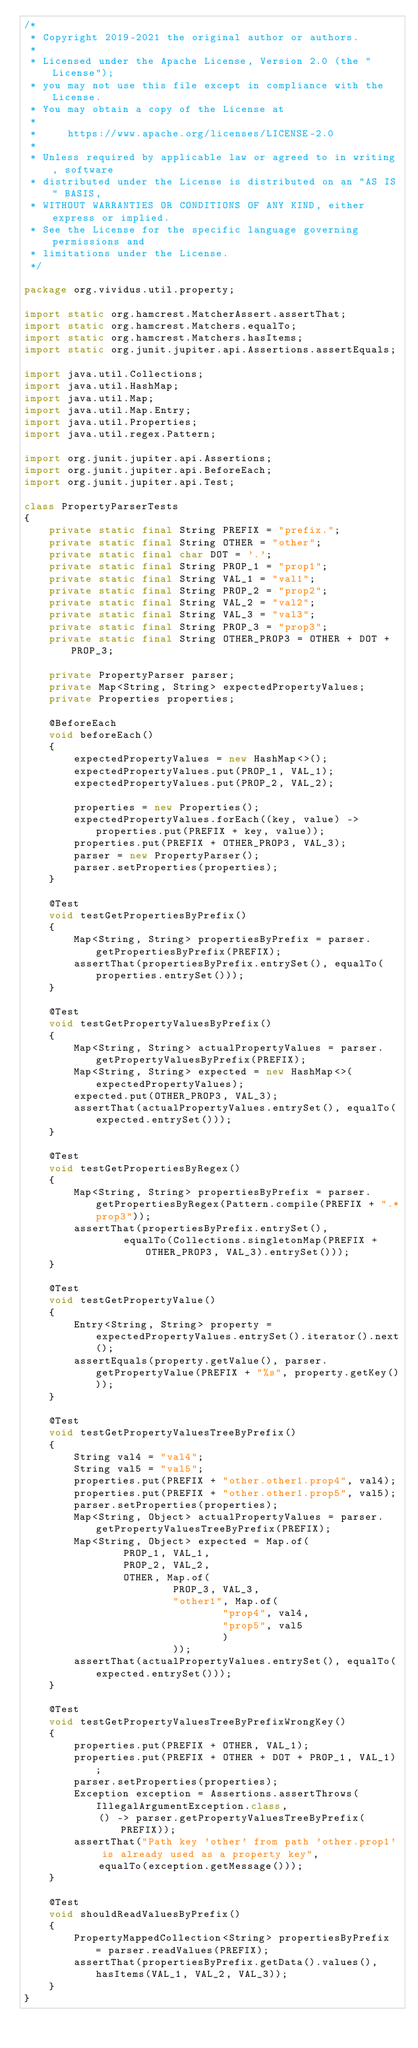<code> <loc_0><loc_0><loc_500><loc_500><_Java_>/*
 * Copyright 2019-2021 the original author or authors.
 *
 * Licensed under the Apache License, Version 2.0 (the "License");
 * you may not use this file except in compliance with the License.
 * You may obtain a copy of the License at
 *
 *     https://www.apache.org/licenses/LICENSE-2.0
 *
 * Unless required by applicable law or agreed to in writing, software
 * distributed under the License is distributed on an "AS IS" BASIS,
 * WITHOUT WARRANTIES OR CONDITIONS OF ANY KIND, either express or implied.
 * See the License for the specific language governing permissions and
 * limitations under the License.
 */

package org.vividus.util.property;

import static org.hamcrest.MatcherAssert.assertThat;
import static org.hamcrest.Matchers.equalTo;
import static org.hamcrest.Matchers.hasItems;
import static org.junit.jupiter.api.Assertions.assertEquals;

import java.util.Collections;
import java.util.HashMap;
import java.util.Map;
import java.util.Map.Entry;
import java.util.Properties;
import java.util.regex.Pattern;

import org.junit.jupiter.api.Assertions;
import org.junit.jupiter.api.BeforeEach;
import org.junit.jupiter.api.Test;

class PropertyParserTests
{
    private static final String PREFIX = "prefix.";
    private static final String OTHER = "other";
    private static final char DOT = '.';
    private static final String PROP_1 = "prop1";
    private static final String VAL_1 = "val1";
    private static final String PROP_2 = "prop2";
    private static final String VAL_2 = "val2";
    private static final String VAL_3 = "val3";
    private static final String PROP_3 = "prop3";
    private static final String OTHER_PROP3 = OTHER + DOT + PROP_3;

    private PropertyParser parser;
    private Map<String, String> expectedPropertyValues;
    private Properties properties;

    @BeforeEach
    void beforeEach()
    {
        expectedPropertyValues = new HashMap<>();
        expectedPropertyValues.put(PROP_1, VAL_1);
        expectedPropertyValues.put(PROP_2, VAL_2);

        properties = new Properties();
        expectedPropertyValues.forEach((key, value) -> properties.put(PREFIX + key, value));
        properties.put(PREFIX + OTHER_PROP3, VAL_3);
        parser = new PropertyParser();
        parser.setProperties(properties);
    }

    @Test
    void testGetPropertiesByPrefix()
    {
        Map<String, String> propertiesByPrefix = parser.getPropertiesByPrefix(PREFIX);
        assertThat(propertiesByPrefix.entrySet(), equalTo(properties.entrySet()));
    }

    @Test
    void testGetPropertyValuesByPrefix()
    {
        Map<String, String> actualPropertyValues = parser.getPropertyValuesByPrefix(PREFIX);
        Map<String, String> expected = new HashMap<>(expectedPropertyValues);
        expected.put(OTHER_PROP3, VAL_3);
        assertThat(actualPropertyValues.entrySet(), equalTo(expected.entrySet()));
    }

    @Test
    void testGetPropertiesByRegex()
    {
        Map<String, String> propertiesByPrefix = parser.getPropertiesByRegex(Pattern.compile(PREFIX + ".*prop3"));
        assertThat(propertiesByPrefix.entrySet(),
                equalTo(Collections.singletonMap(PREFIX + OTHER_PROP3, VAL_3).entrySet()));
    }

    @Test
    void testGetPropertyValue()
    {
        Entry<String, String> property = expectedPropertyValues.entrySet().iterator().next();
        assertEquals(property.getValue(), parser.getPropertyValue(PREFIX + "%s", property.getKey()));
    }

    @Test
    void testGetPropertyValuesTreeByPrefix()
    {
        String val4 = "val4";
        String val5 = "val5";
        properties.put(PREFIX + "other.other1.prop4", val4);
        properties.put(PREFIX + "other.other1.prop5", val5);
        parser.setProperties(properties);
        Map<String, Object> actualPropertyValues = parser.getPropertyValuesTreeByPrefix(PREFIX);
        Map<String, Object> expected = Map.of(
                PROP_1, VAL_1,
                PROP_2, VAL_2,
                OTHER, Map.of(
                        PROP_3, VAL_3,
                        "other1", Map.of(
                                "prop4", val4,
                                "prop5", val5
                                )
                        ));
        assertThat(actualPropertyValues.entrySet(), equalTo(expected.entrySet()));
    }

    @Test
    void testGetPropertyValuesTreeByPrefixWrongKey()
    {
        properties.put(PREFIX + OTHER, VAL_1);
        properties.put(PREFIX + OTHER + DOT + PROP_1, VAL_1);
        parser.setProperties(properties);
        Exception exception = Assertions.assertThrows(IllegalArgumentException.class,
            () -> parser.getPropertyValuesTreeByPrefix(PREFIX));
        assertThat("Path key 'other' from path 'other.prop1' is already used as a property key",
            equalTo(exception.getMessage()));
    }

    @Test
    void shouldReadValuesByPrefix()
    {
        PropertyMappedCollection<String> propertiesByPrefix = parser.readValues(PREFIX);
        assertThat(propertiesByPrefix.getData().values(), hasItems(VAL_1, VAL_2, VAL_3));
    }
}
</code> 